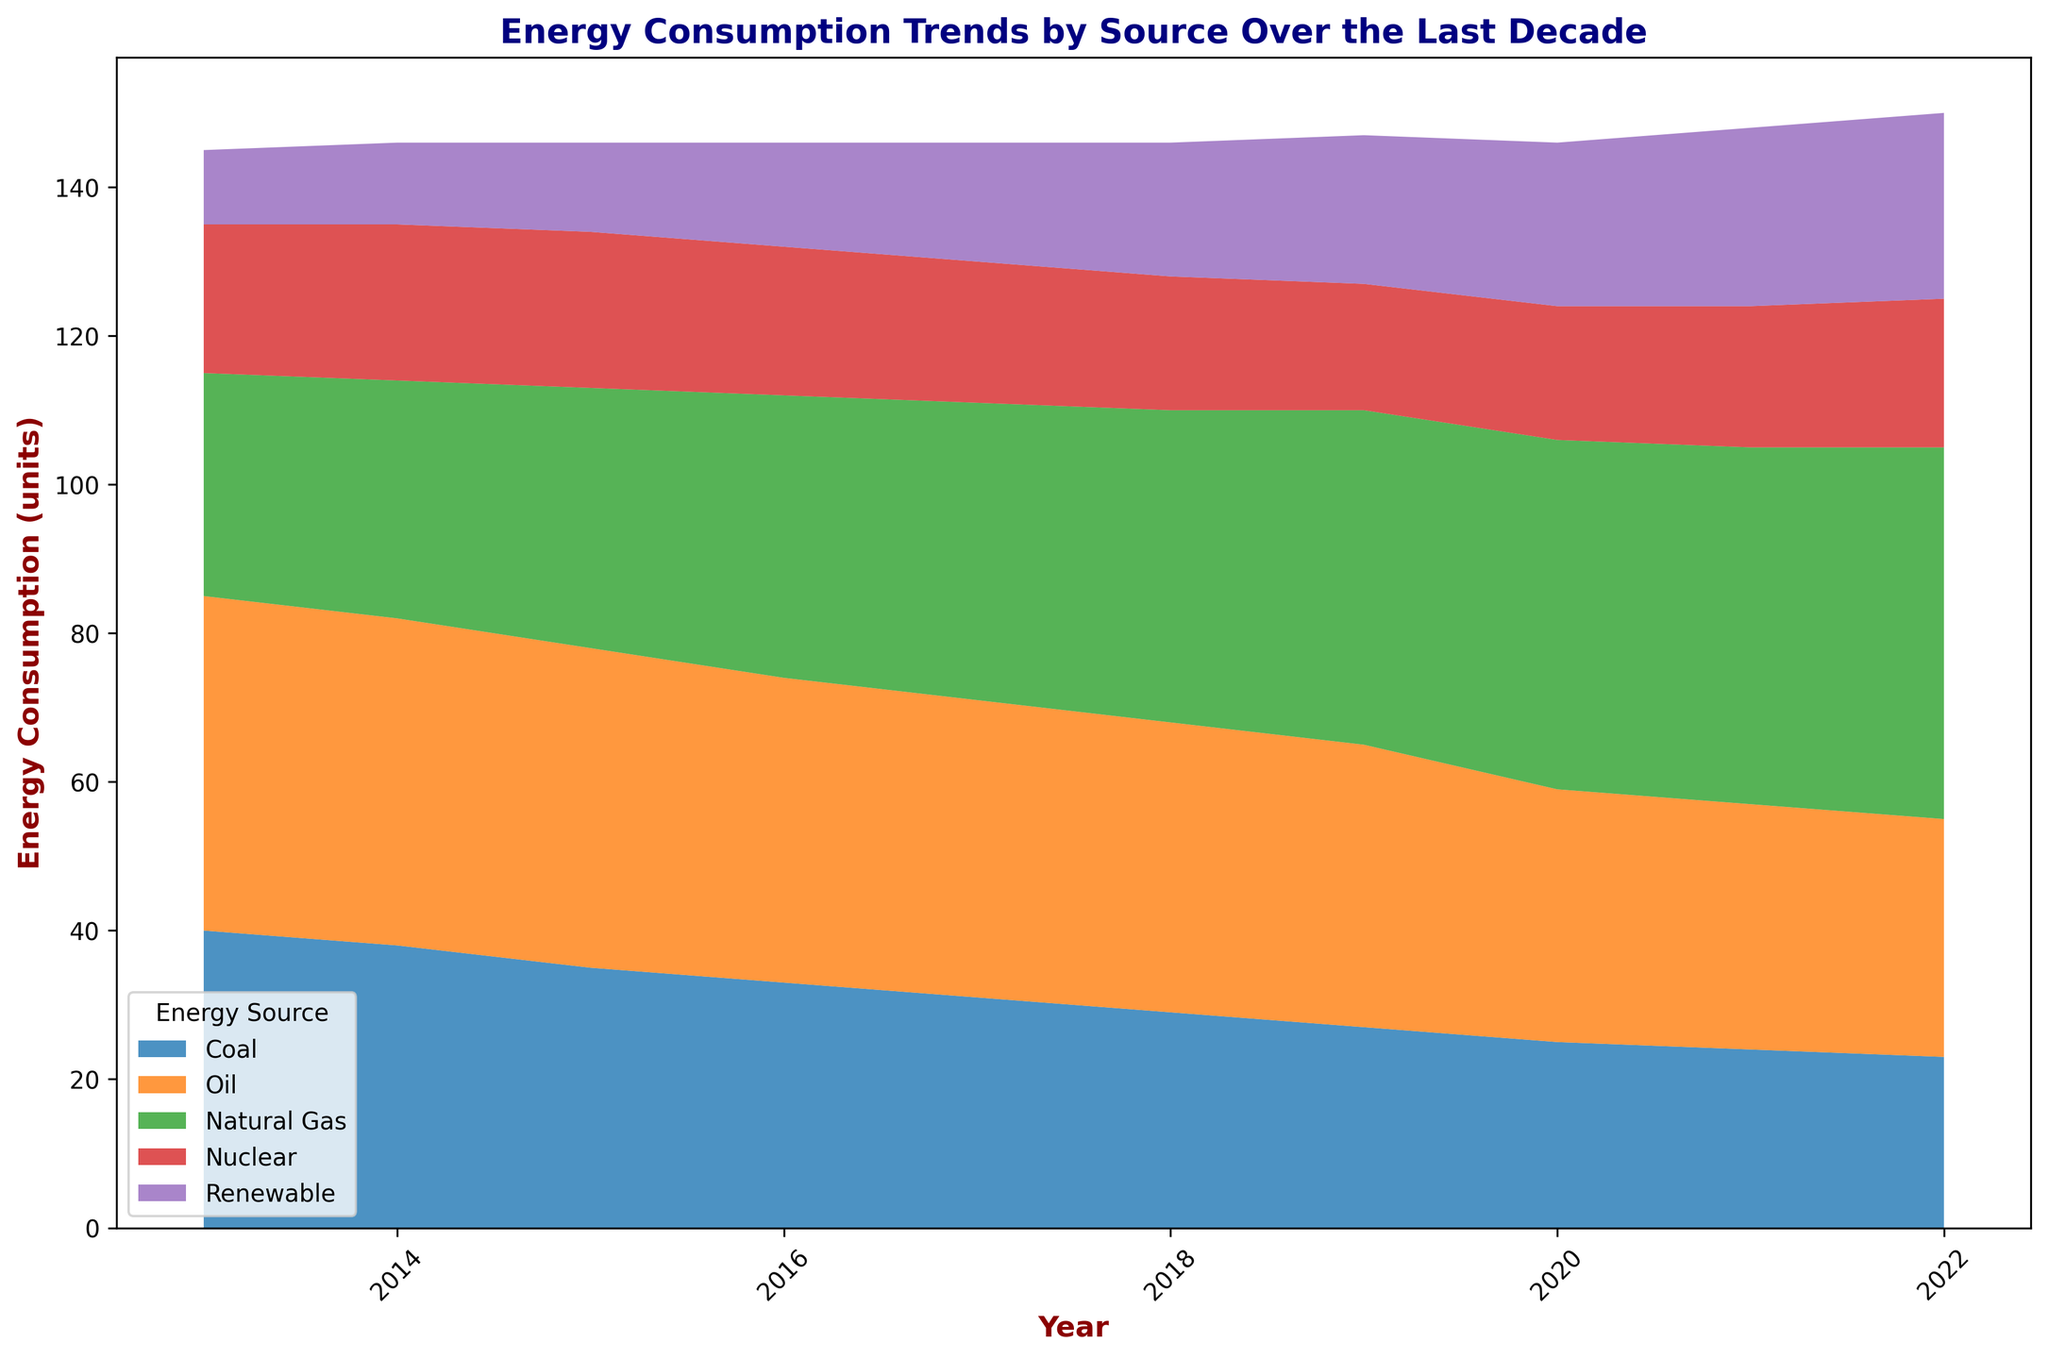What is the trend of coal energy consumption from 2013 to 2022? The plot shows the area dedicated to coal consumption decreasing steadily from 2013 to 2022. Starting from 40 units in 2013, coal consumption decreases incrementally each year, ending at 23 units in 2022.
Answer: Decreasing Which energy source saw the most significant increase in consumption from 2013 to 2022? By examining the area corresponding to each energy source, it is clear that renewable energy shows the most significant increase. It started at 10 units in 2013 and grew to 25 units in 2022.
Answer: Renewable In what year did natural gas consumption surpass oil consumption? Looking at the point where the areas of natural gas and oil intersect, natural gas consumption surpasses oil consumption between 2015 and 2016. It's evident that by 2016, natural gas was on top.
Answer: 2016 Compare the consumption of renewable energy in 2013 and 2022. In 2013, the consumption of renewable energy is 10 units. In 2022, it rises to 25 units. The change from 10 to 25 units represents an increase of 15 units.
Answer: 15 units increase What is the combined energy consumption of coal and oil in 2020? The plot shows coal at 25 units and oil at 34 units in 2020. Adding these values, the combined consumption is 25 + 34 = 59 units.
Answer: 59 units Which energy source has the most stable consumption trend from 2013 to 2022? By observing the areas representing each energy source, nuclear energy appears the most stable, with slight fluctuations around 20 units throughout the entire timeline.
Answer: Nuclear How does the renewable energy consumption in 2019 compare to nuclear energy in the same year? In 2019, renewable energy consumption is 20 units, while nuclear energy consumption is 17 units. The renewable energy is higher by 3 units in 2019.
Answer: Renewable energy is 3 units higher Between which years did oil consumption see the largest decline? The plot indicates the difference between successive years. The largest decline in oil consumption is between 2019 (38 units) to 2020 (34 units), a 4 unit decrease.
Answer: 2019 to 2020 What is the average annual consumption of natural gas from 2013 to 2022? Sum the natural gas units over the years: 30 + 32 + 35 + 38 + 40 + 42 + 45 + 47 + 48 + 50 = 407. Divide this sum by the number of years (10), we get 407 / 10 = 40.7 units.
Answer: 40.7 units Which source had the lowest consumption in 2013 and what was the value? In 2013, the smallest area represents renewable energy, with a consumption of 10 units.
Answer: Renewable, 10 units 